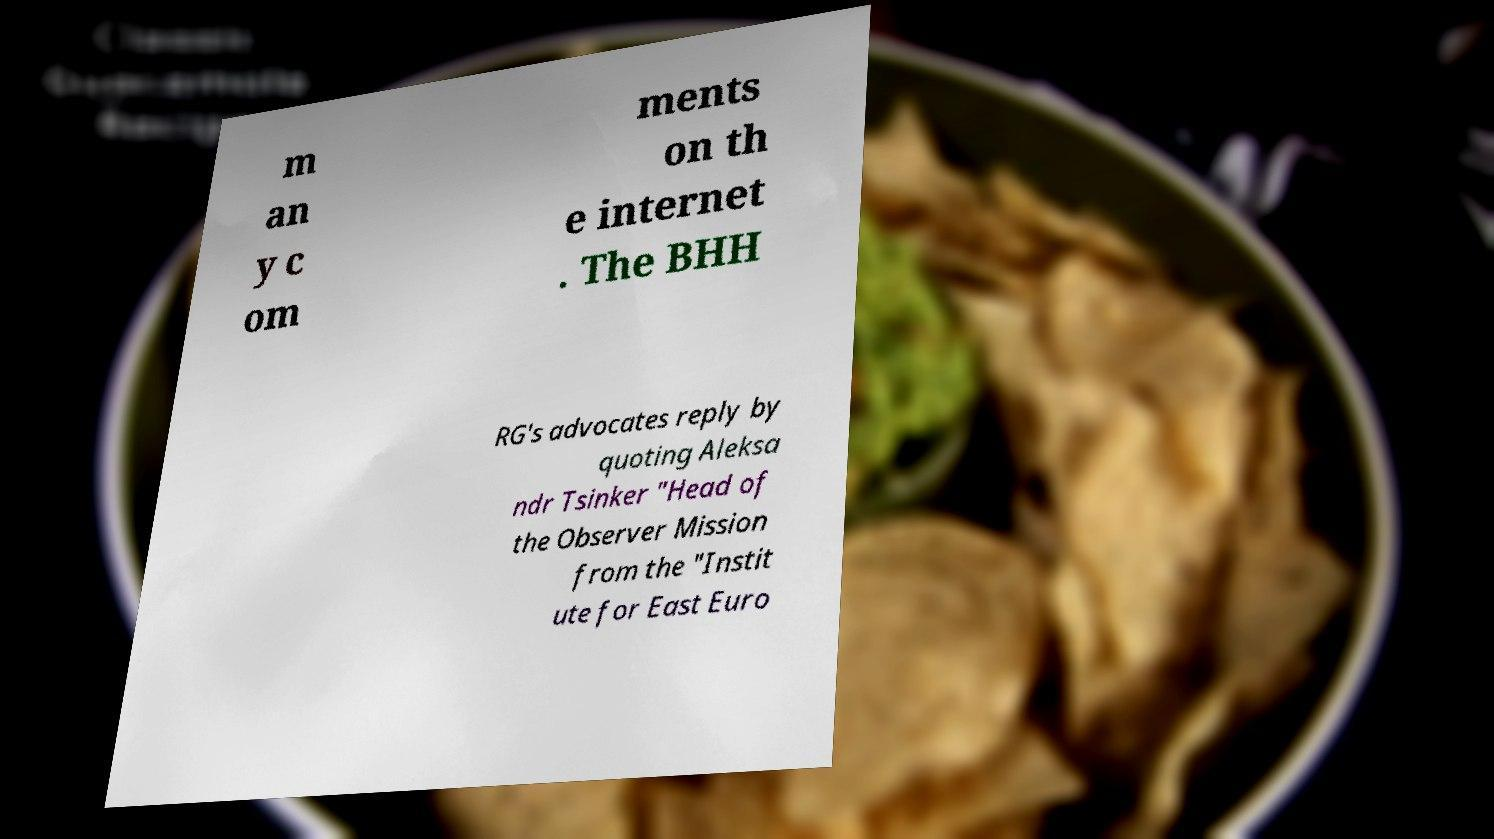Please read and relay the text visible in this image. What does it say? m an y c om ments on th e internet . The BHH RG's advocates reply by quoting Aleksa ndr Tsinker "Head of the Observer Mission from the "Instit ute for East Euro 